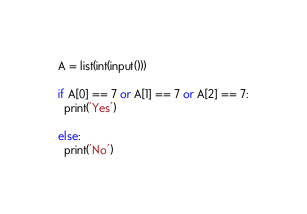Convert code to text. <code><loc_0><loc_0><loc_500><loc_500><_Python_>A = list(int(input()))

if A[0] == 7 or A[1] == 7 or A[2] == 7:
  print('Yes')
  
else:
  print('No')</code> 